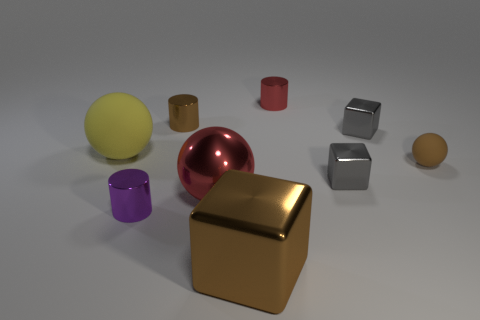Subtract all big spheres. How many spheres are left? 1 Subtract all brown balls. How many balls are left? 2 Subtract all spheres. How many objects are left? 6 Subtract all red spheres. How many gray blocks are left? 2 Add 2 large things. How many large things are left? 5 Add 4 big matte objects. How many big matte objects exist? 5 Subtract 1 brown spheres. How many objects are left? 8 Subtract 2 blocks. How many blocks are left? 1 Subtract all purple spheres. Subtract all blue blocks. How many spheres are left? 3 Subtract all gray metal things. Subtract all matte spheres. How many objects are left? 5 